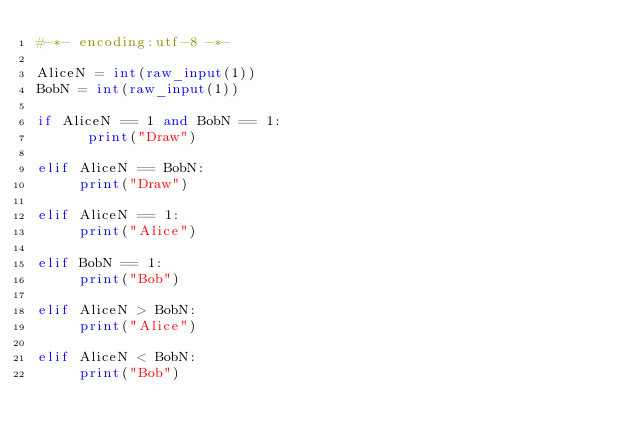<code> <loc_0><loc_0><loc_500><loc_500><_Python_>#-*- encoding:utf-8 -*-

AliceN = int(raw_input(1))
BobN = int(raw_input(1))

if AliceN == 1 and BobN == 1:
      print("Draw")
      
elif AliceN == BobN:
     print("Draw")
     
elif AliceN == 1:
     print("Alice")
     
elif BobN == 1:
     print("Bob")
     
elif AliceN > BobN:
     print("Alice")
     
elif AliceN < BobN:
     print("Bob")</code> 